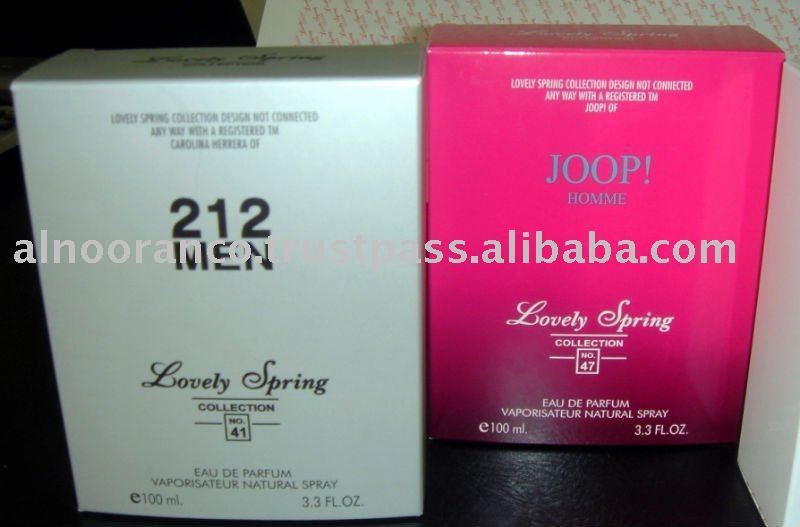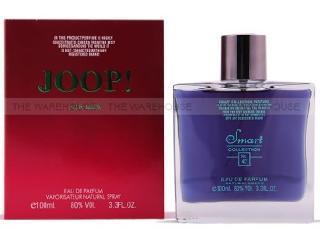The first image is the image on the left, the second image is the image on the right. Given the left and right images, does the statement "The  glass perfume bottle furthest to the right in the right image is purple." hold true? Answer yes or no. Yes. 